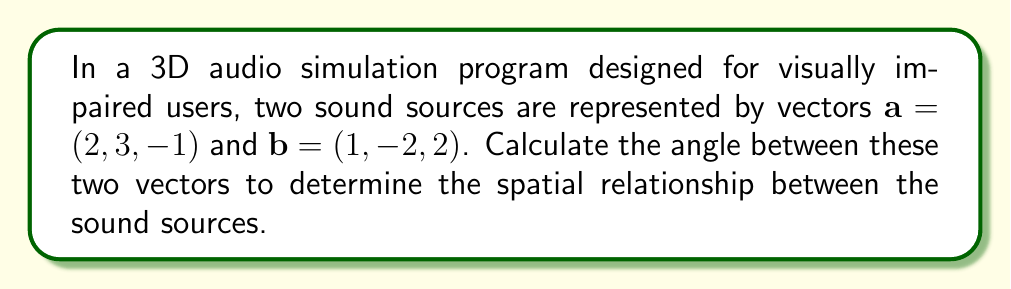Give your solution to this math problem. To find the angle between two vectors in three-dimensional space, we can use the dot product formula:

$$\cos \theta = \frac{\mathbf{a} \cdot \mathbf{b}}{|\mathbf{a}||\mathbf{b}|}$$

Where $\theta$ is the angle between vectors $\mathbf{a}$ and $\mathbf{b}$, $\mathbf{a} \cdot \mathbf{b}$ is their dot product, and $|\mathbf{a}|$ and $|\mathbf{b}|$ are their magnitudes.

Step 1: Calculate the dot product $\mathbf{a} \cdot \mathbf{b}$
$$\mathbf{a} \cdot \mathbf{b} = (2)(1) + (3)(-2) + (-1)(2) = 2 - 6 - 2 = -6$$

Step 2: Calculate the magnitudes $|\mathbf{a}|$ and $|\mathbf{b}|$
$$|\mathbf{a}| = \sqrt{2^2 + 3^2 + (-1)^2} = \sqrt{4 + 9 + 1} = \sqrt{14}$$
$$|\mathbf{b}| = \sqrt{1^2 + (-2)^2 + 2^2} = \sqrt{1 + 4 + 4} = 3$$

Step 3: Apply the dot product formula
$$\cos \theta = \frac{-6}{\sqrt{14} \cdot 3} = \frac{-6}{3\sqrt{14}}$$

Step 4: Take the inverse cosine (arccos) of both sides
$$\theta = \arccos\left(\frac{-6}{3\sqrt{14}}\right)$$

Step 5: Calculate the result (rounded to two decimal places)
$$\theta \approx 2.48 \text{ radians}$$

To convert to degrees, multiply by $\frac{180}{\pi}$:
$$\theta \approx 2.48 \cdot \frac{180}{\pi} \approx 142.13°$$
Answer: The angle between the two vectors is approximately 2.48 radians or 142.13 degrees. 